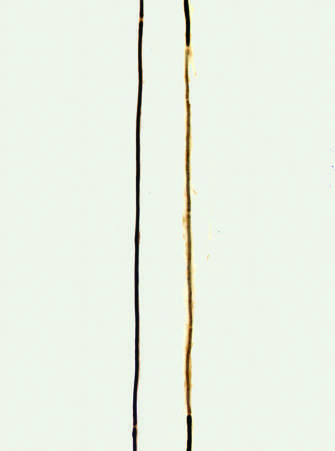do the histone subunits allow for examination of individual axons of peripheral nerves?
Answer the question using a single word or phrase. No 